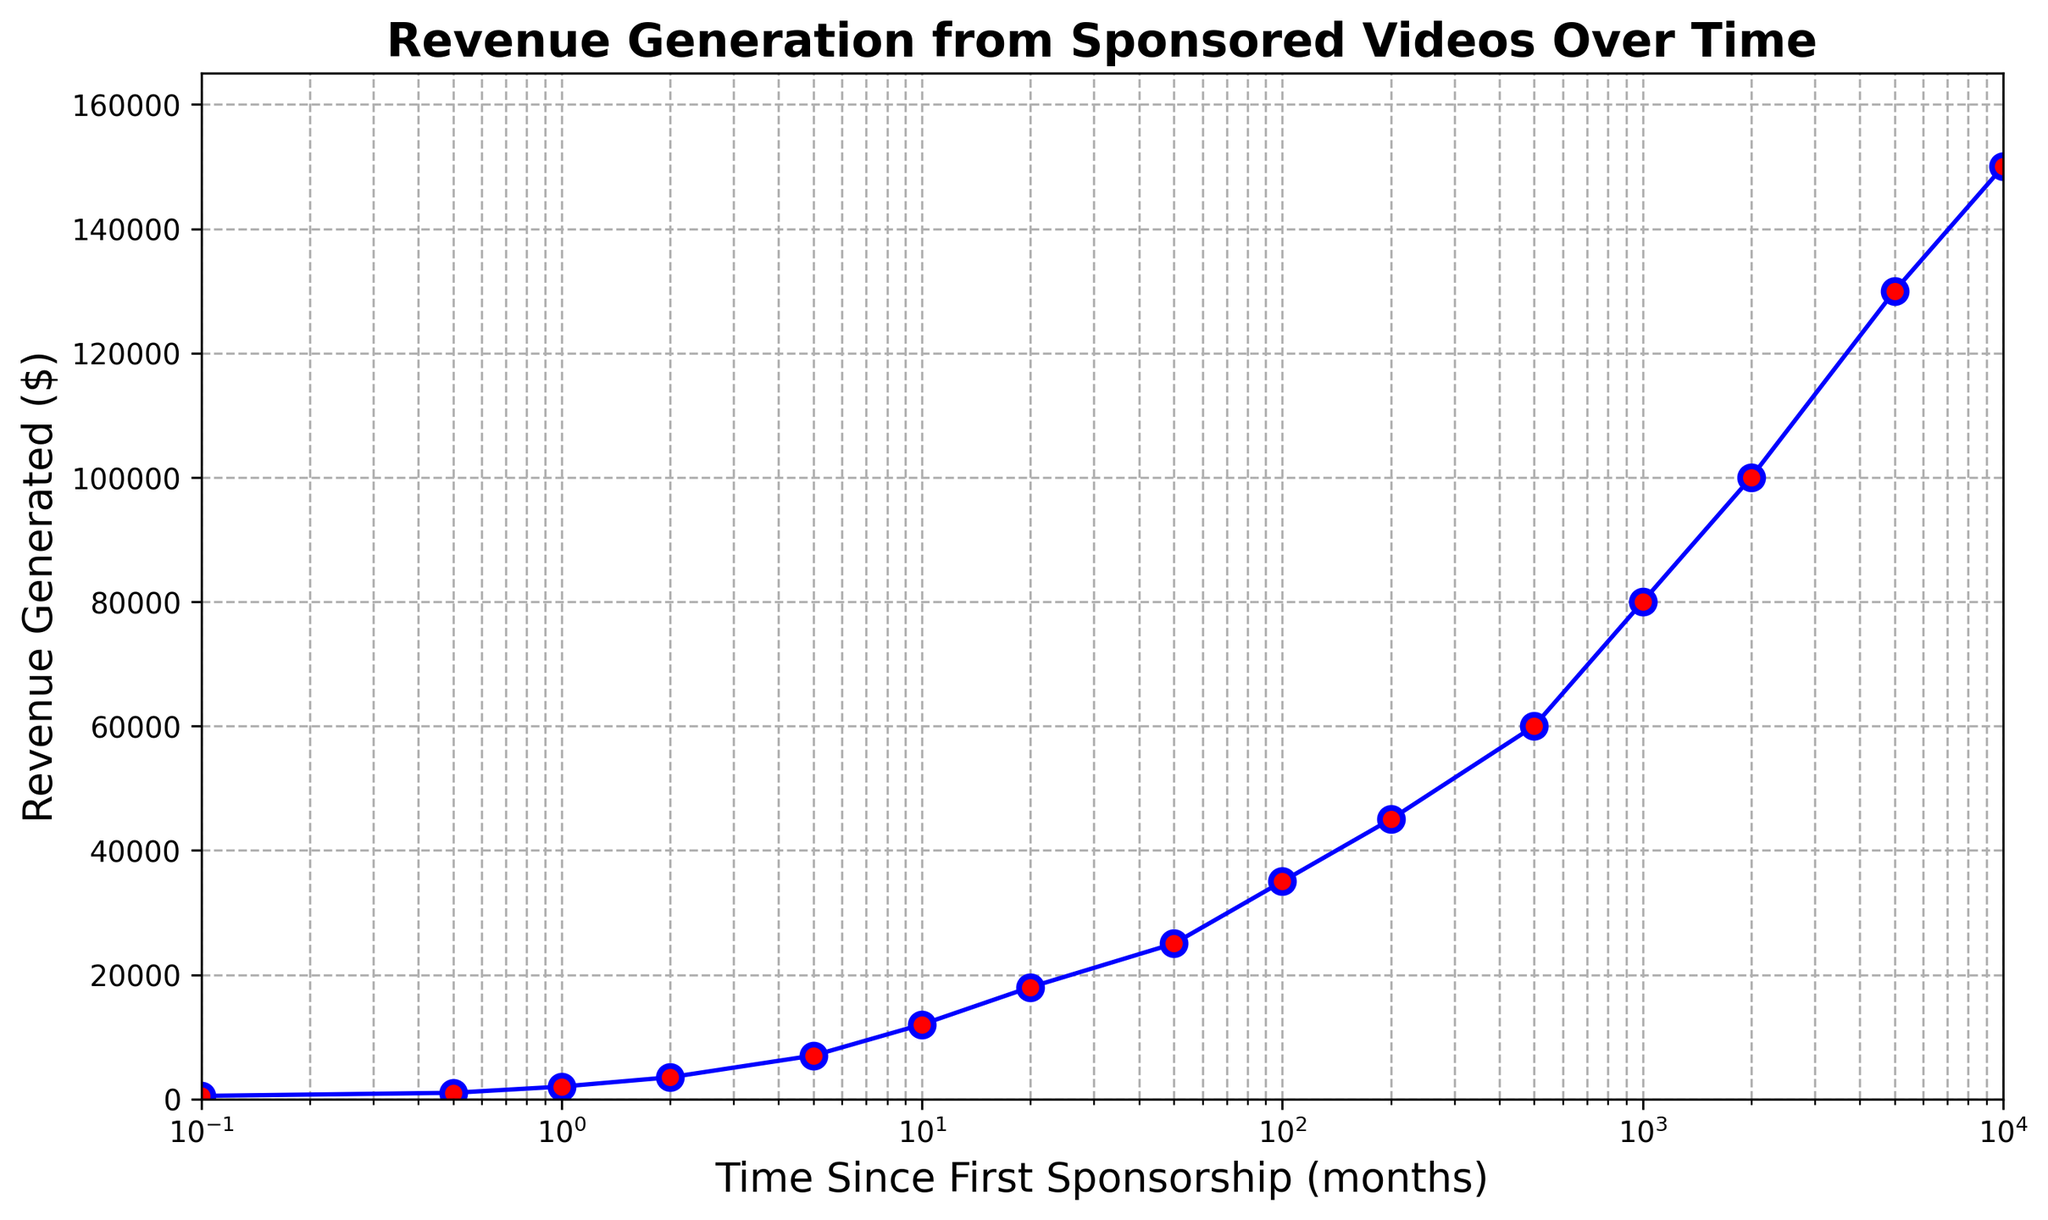What is the revenue generated at 100 months since the first sponsorship? The plot shows data points with revenue generated on the y-axis and time since first sponsorship on the x-axis. At x = 100 months, the y value is 35,000 dollars.
Answer: 35,000 dollars How much additional revenue is generated from 50 months to 200 months? At 50 months, the revenue is 25,000 dollars, and at 200 months, the revenue is 45,000 dollars. The difference is 45,000 - 25,000 = 20,000 dollars.
Answer: 20,000 dollars What is the average revenue generated over the first 10 months? The revenues for 0.1, 0.5, 1, 2, 5, and 10 months are 500, 1000, 2000, 3500, 7000, and 12000 dollars respectively. Summing these gives 500 + 1000 + 2000 + 3500 + 7000 + 12000 = 26,000 dollars. There are 6 points, so the average is 26,000 / 6 ≈ 4,333.33 dollars.
Answer: 4,333.33 dollars What is the total revenue generated up to 100 months? By adding the revenues from 0.1 month up to 100 months (500 + 1000 + 2000 + 3500 + 7000 + 12000 + 18000 + 25000 + 35000), we get 102,000 dollars.
Answer: 102,000 dollars Which time point shows the highest revenue generated? By examining the y-axis for the highest y-value, 10,000 months shows the highest revenue of 150,000 dollars.
Answer: 10,000 months Does revenue generation increase steadily over time? The visual inspection of the plot shows the revenue increases in a generally upward trend, becoming steeper as time progresses, indicating an increase in revenue over time.
Answer: Yes Among 20, 200, and 1000 months, which has the lowest revenue generated? According to the plot, revenues at 20 months, 200 months, and 1000 months are 18,000, 45,000, and 80,000 dollars respectively. The lowest is at 20 months (18,000 dollars).
Answer: 20 months From the chart, how much revenue is generated at 5000 months? Locating the point at 5000 months on the x-axis, the corresponding y value is 130,000 dollars.
Answer: 130,000 dollars What is the difference in revenue generated between 2000 months and 10000 months? From the data points, revenue at 2000 months is 100,000 dollars and at 10000 months is 150,000 dollars. The difference is 150,000 - 100,000 = 50,000 dollars.
Answer: 50,000 dollars How much more revenue is generated at 10 months compared to 0.1 months? At 0.1 months, the revenue is 500 dollars, and at 10 months, it is 12,000 dollars. The difference is 12,000 - 500 = 11,500 dollars.
Answer: 11,500 dollars 